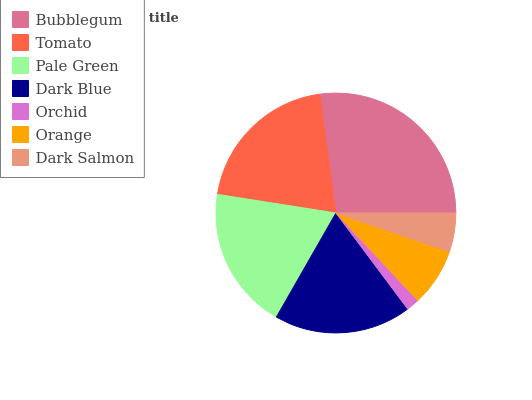Is Orchid the minimum?
Answer yes or no. Yes. Is Bubblegum the maximum?
Answer yes or no. Yes. Is Tomato the minimum?
Answer yes or no. No. Is Tomato the maximum?
Answer yes or no. No. Is Bubblegum greater than Tomato?
Answer yes or no. Yes. Is Tomato less than Bubblegum?
Answer yes or no. Yes. Is Tomato greater than Bubblegum?
Answer yes or no. No. Is Bubblegum less than Tomato?
Answer yes or no. No. Is Dark Blue the high median?
Answer yes or no. Yes. Is Dark Blue the low median?
Answer yes or no. Yes. Is Tomato the high median?
Answer yes or no. No. Is Pale Green the low median?
Answer yes or no. No. 